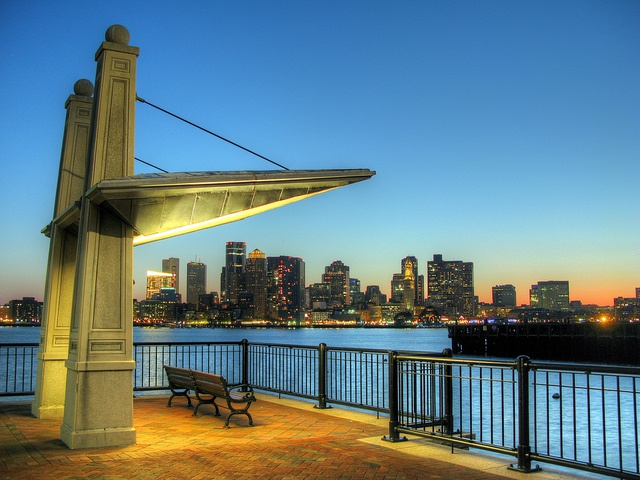Describe the objects in this image and their specific colors. I can see a bench in blue, black, maroon, olive, and gray tones in this image. 